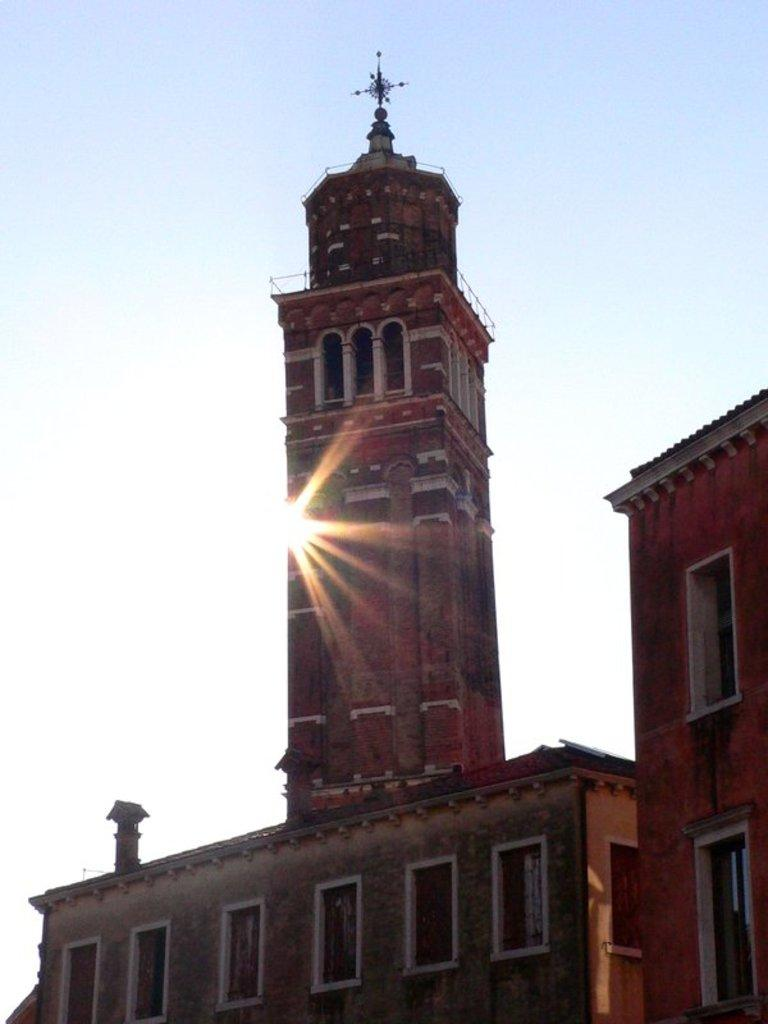What type of structures can be seen in the image? There are buildings in the image. What celestial body is visible in the background of the image? The sun is visible in the background of the image. What else can be seen in the background of the image? The sky is visible in the background of the image. Can you tell me how many squirrels are climbing on the buildings in the image? There are no squirrels visible in the image; it only features buildings, the sun, and the sky. 